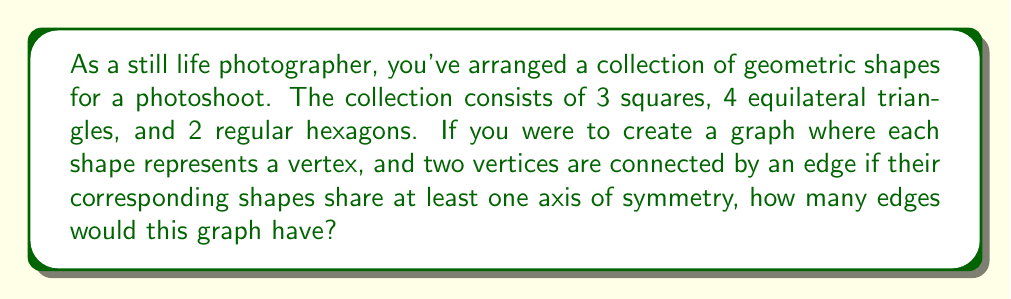Solve this math problem. To solve this problem, we need to follow these steps:

1. Determine the number of axes of symmetry for each shape:
   - Square: 4 axes (2 diagonals, 2 bisecting opposite sides)
   - Equilateral triangle: 3 axes (bisecting each vertex)
   - Regular hexagon: 6 axes (3 diagonals, 3 bisecting opposite sides)

2. Determine which shapes share axes of symmetry:
   - Squares and hexagons share 2 axes (vertical and horizontal)
   - Triangles and hexagons share 3 axes (bisecting each vertex of the triangle)
   - Squares and triangles share 1 axis (vertical for square, bisecting a vertex for triangle)

3. Count the number of edges:
   - Between squares: $\binom{3}{2} = 3$ edges
   - Between triangles: $\binom{4}{2} = 6$ edges
   - Between hexagons: $\binom{2}{2} = 1$ edge
   - Between squares and triangles: $3 \times 4 = 12$ edges
   - Between squares and hexagons: $3 \times 2 = 6$ edges
   - Between triangles and hexagons: $4 \times 2 = 8$ edges

4. Sum up all the edges:

   $$\text{Total edges} = 3 + 6 + 1 + 12 + 6 + 8 = 36$$

Therefore, the graph would have 36 edges.

[asy]
import geometry;

size(200);

pair[] squares = {(0,0), (1,0), (2,0)};
pair[] triangles = {(0,1), (1,1), (2,1), (3,1)};
pair[] hexagons = {(0,2), (3,2)};

for (pair p : squares) {
  fill(shift(p)*scale(0.4)*unitcircle, blue);
  draw(shift(p)*scale(0.4)*unitcircle);
}

for (pair p : triangles) {
  fill(shift(p)*scale(0.4)*polygon(3), green);
  draw(shift(p)*scale(0.4)*polygon(3));
}

for (pair p : hexagons) {
  fill(shift(p)*scale(0.4)*polygon(6), red);
  draw(shift(p)*scale(0.4)*polygon(6));
}

for (int i = 0; i < squares.length; ++i) {
  for (int j = i+1; j < squares.length; ++j) {
    draw(squares[i]--squares[j]);
  }
}

for (int i = 0; i < triangles.length; ++i) {
  for (int j = i+1; j < triangles.length; ++j) {
    draw(triangles[i]--triangles[j]);
  }
}

draw(hexagons[0]--hexagons[1]);

for (pair s : squares) {
  for (pair t : triangles) {
    draw(s--t);
  }
  for (pair h : hexagons) {
    draw(s--h);
  }
}

for (pair t : triangles) {
  for (pair h : hexagons) {
    draw(t--h);
  }
}

label("Squares", (1,-0.5));
label("Triangles", (1.5,1.5));
label("Hexagons", (1.5,2.5));
[/asy]
Answer: The graph would have 36 edges. 